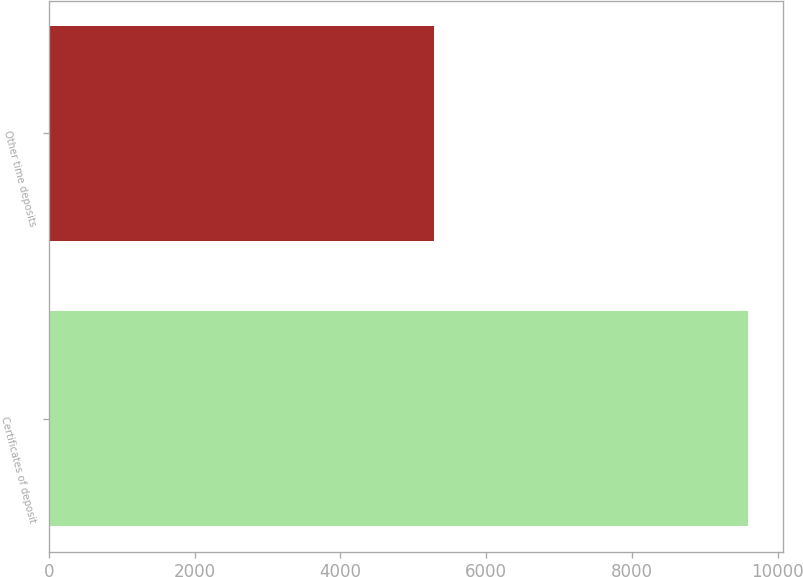Convert chart to OTSL. <chart><loc_0><loc_0><loc_500><loc_500><bar_chart><fcel>Certificates of deposit<fcel>Other time deposits<nl><fcel>9589<fcel>5286<nl></chart> 